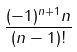Convert formula to latex. <formula><loc_0><loc_0><loc_500><loc_500>\frac { ( - 1 ) ^ { n + 1 } n } { ( n - 1 ) ! }</formula> 